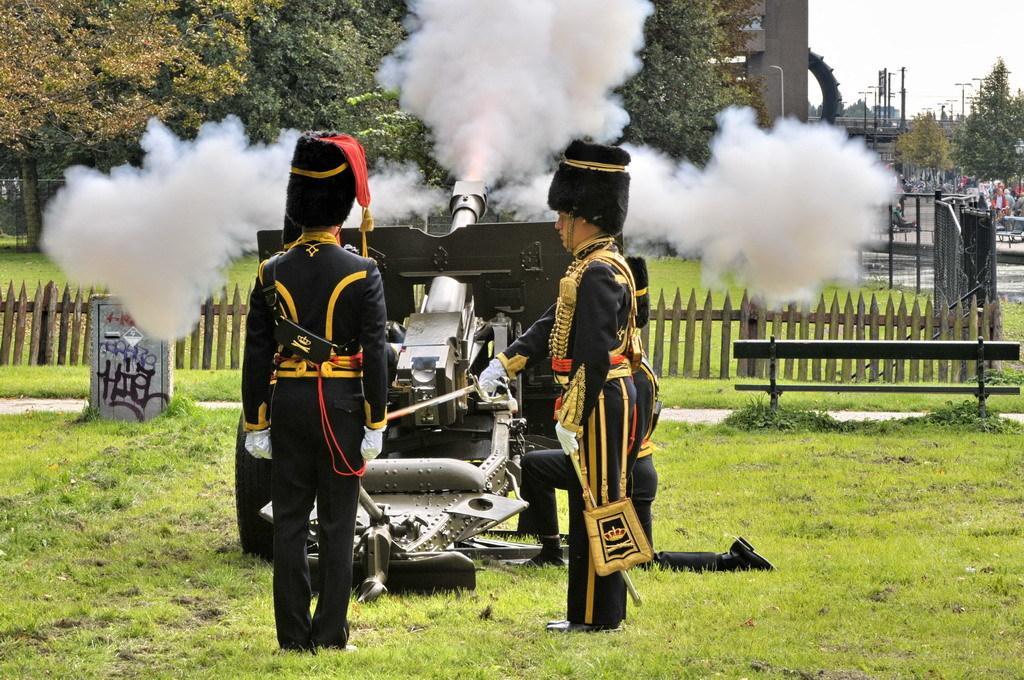How many people are in the image? There are two persons in the image. What are the people wearing on their heads? Both persons are wearing hats. What can be seen in the image besides the people? There is a vehicle, grass, a fence, trees, a pole, and the sky visible in the image. What is happening with the vehicle in the image? The vehicle has smoke coming out of it. What type of vegetation is present in the image? There is grass and trees visible in the image. What type of texture can be seen on the beetle's shell in the image? There is no beetle present in the image, so it is not possible to determine the texture of its shell. 